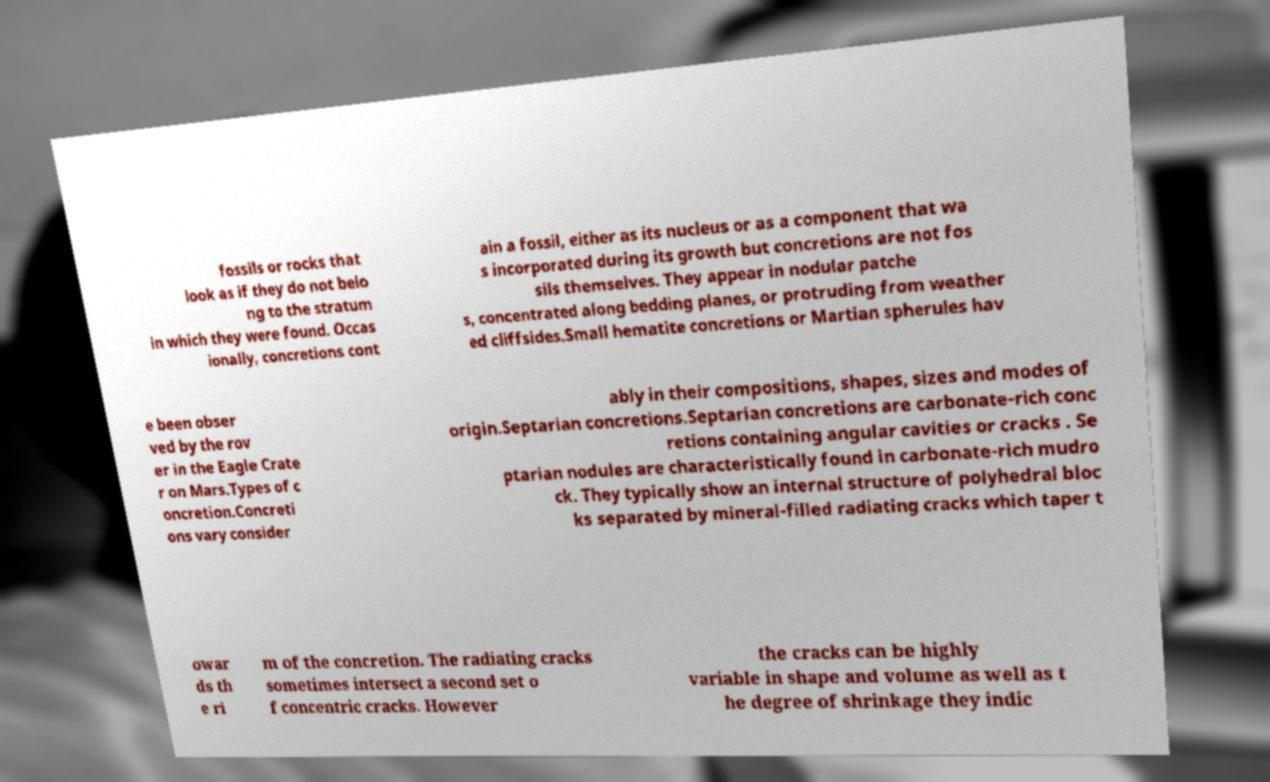Could you extract and type out the text from this image? fossils or rocks that look as if they do not belo ng to the stratum in which they were found. Occas ionally, concretions cont ain a fossil, either as its nucleus or as a component that wa s incorporated during its growth but concretions are not fos sils themselves. They appear in nodular patche s, concentrated along bedding planes, or protruding from weather ed cliffsides.Small hematite concretions or Martian spherules hav e been obser ved by the rov er in the Eagle Crate r on Mars.Types of c oncretion.Concreti ons vary consider ably in their compositions, shapes, sizes and modes of origin.Septarian concretions.Septarian concretions are carbonate-rich conc retions containing angular cavities or cracks . Se ptarian nodules are characteristically found in carbonate-rich mudro ck. They typically show an internal structure of polyhedral bloc ks separated by mineral-filled radiating cracks which taper t owar ds th e ri m of the concretion. The radiating cracks sometimes intersect a second set o f concentric cracks. However the cracks can be highly variable in shape and volume as well as t he degree of shrinkage they indic 